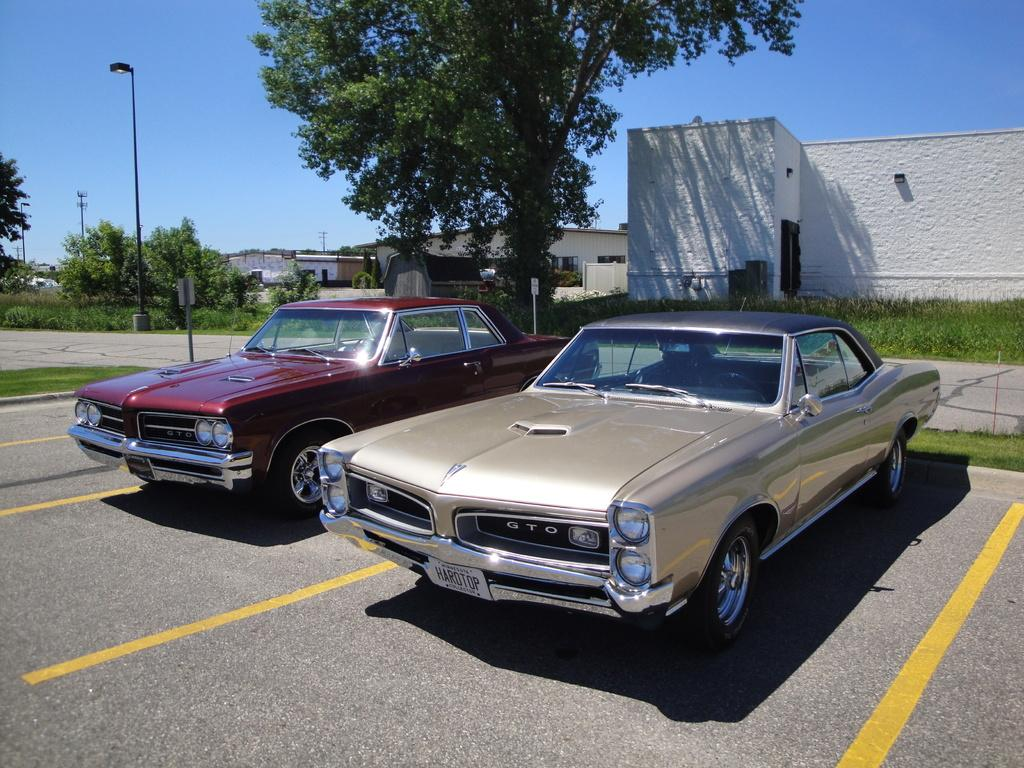What type of structures can be seen in the image? There are buildings in the image. What other natural elements are present in the image? There are trees in the image. What type of lighting is present in the image? There are pole lights in the image. What type of vehicles can be seen in the image? There are cars parked in the image. What is the color of the sky in the image? The sky is blue in the image. What type of vessel is floating in the image? There is no vessel present in the image; it features buildings, trees, pole lights, cars, and a blue sky. How many eggs are visible in the image? There are no eggs present in the image. 